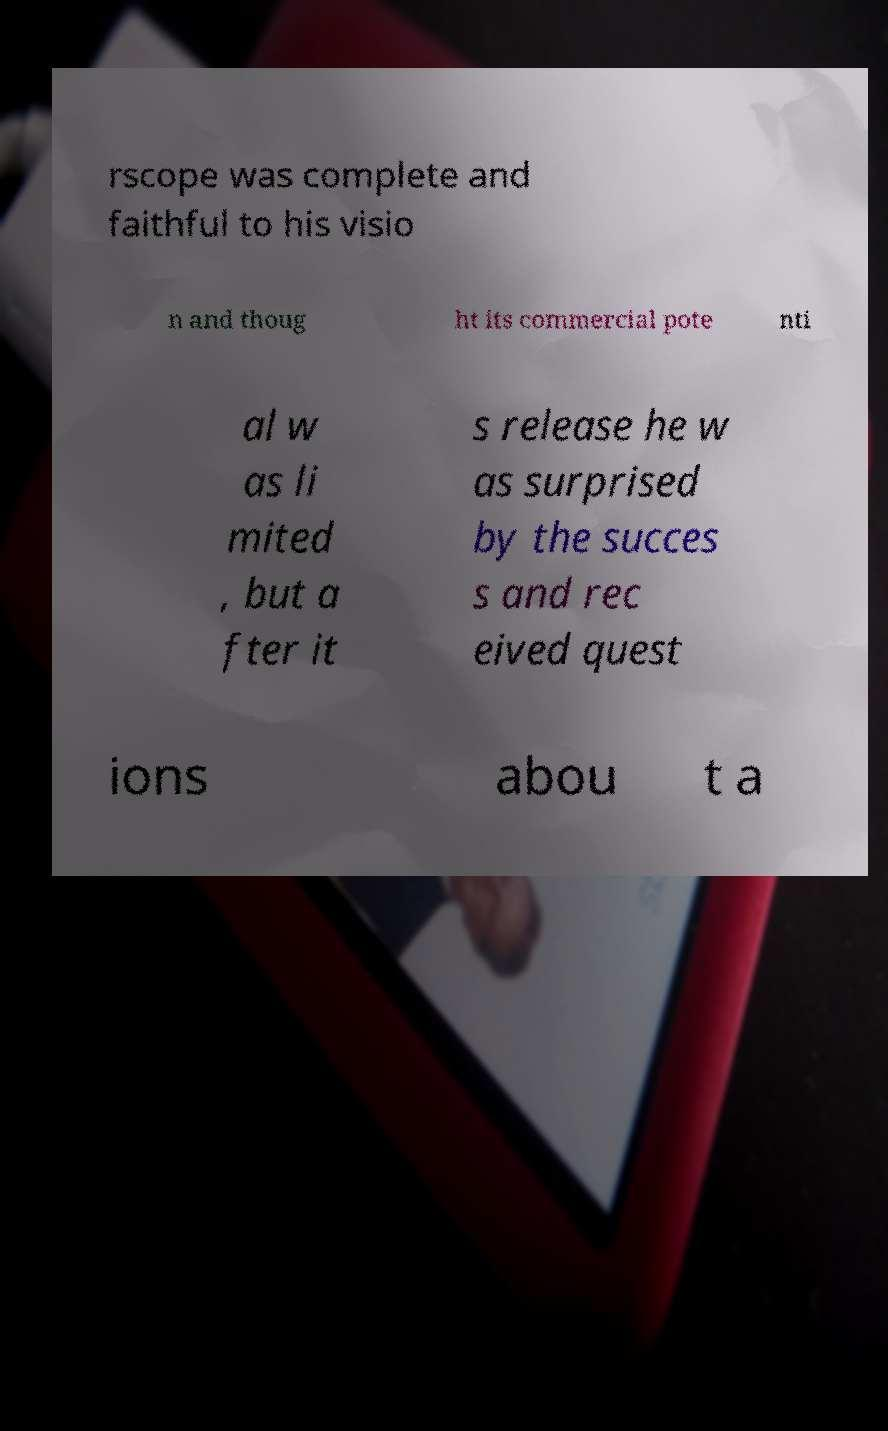What messages or text are displayed in this image? I need them in a readable, typed format. rscope was complete and faithful to his visio n and thoug ht its commercial pote nti al w as li mited , but a fter it s release he w as surprised by the succes s and rec eived quest ions abou t a 